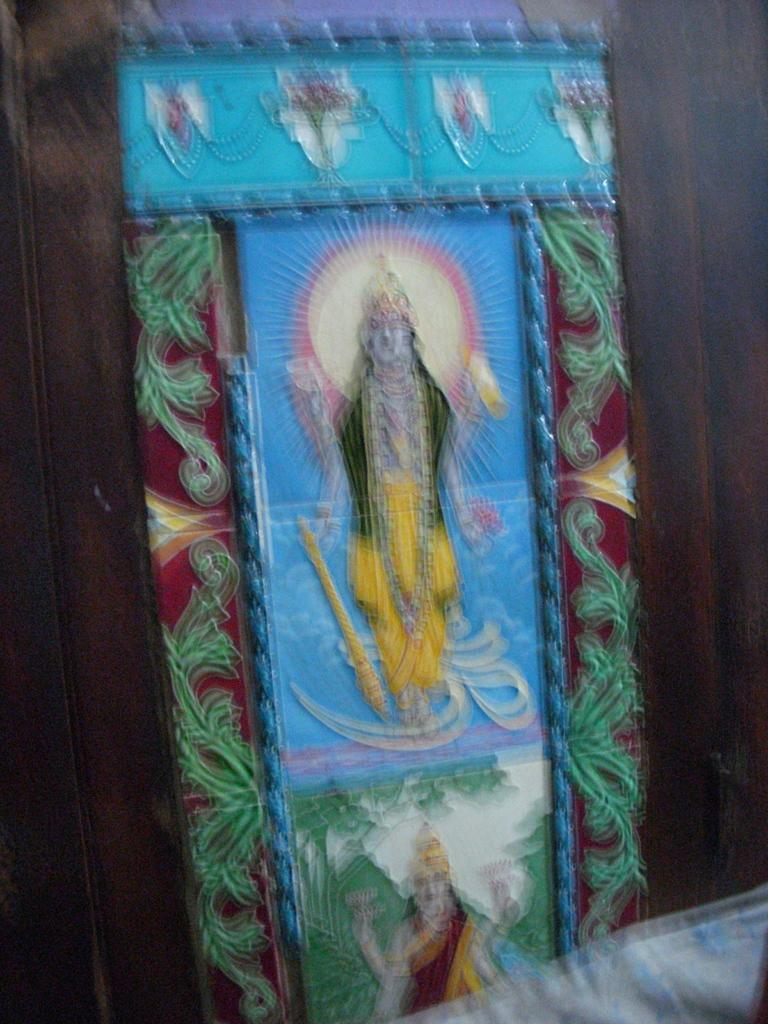Describe this image in one or two sentences. This is a blurred image. In this image there is a painting of a god and goddess. 